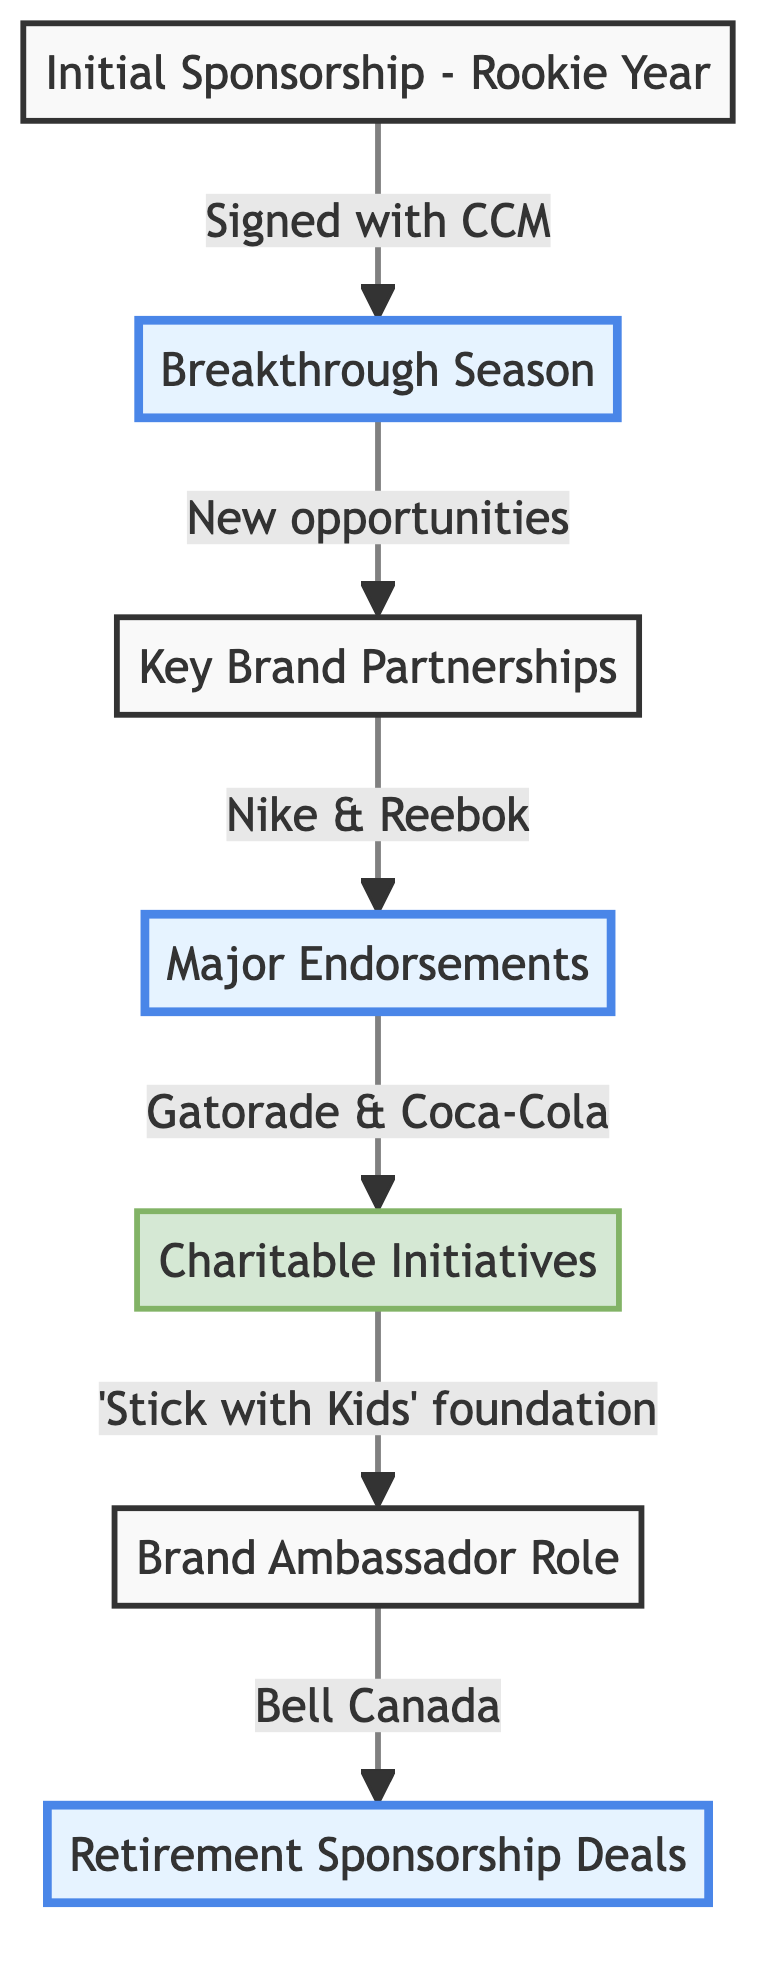What is the first step in the journey? The first step is the "Initial Sponsorship - Rookie Year," which is where the journey begins. This node indicates the signing of the first endorsement deal with CCM.
Answer: Initial Sponsorship - Rookie Year How many major endorsements are listed in the flow chart? There are two major endorsements listed in the flow chart: Gatorade and Coca-Cola. You can identify these from the "Major Endorsements" node connection.
Answer: 2 What partnership follows the "Breakthrough Season"? After achieving prominence in the "Breakthrough Season," the next step is "Key Brand Partnerships" where relationships with brands like Nike and Reebok are established.
Answer: Key Brand Partnerships What charitable initiative is mentioned? The flow chart mentions the "Stick with Kids" foundation, which focuses on supporting youth hockey programs. This is found under the "Charitable Initiatives" node.
Answer: Stick with Kids Which brand did the athlete represent as an ambassador? The athlete became a brand ambassador for Bell Canada, as indicated in the "Brand Ambassador Role" node.
Answer: Bell Canada What signifies a move from playing to endorsing after retirement? The transition is represented by the "Retirement Sponsorship Deals," where the athlete continues collaborations with existing brands and establishes new partnerships, such as with EA Sports.
Answer: Retirement Sponsorship Deals Which two brands are part of "Key Brand Partnerships"? Nike and Reebok are the two brands mentioned in the "Key Brand Partnerships" node. This node indicates the established relationships with those brands.
Answer: Nike and Reebok What is the connection between "Major Endorsements" and "Charitable Initiatives"? The connection indicates that following the "Major Endorsements" (Gatorade and Coca-Cola), there is a progression to "Charitable Initiatives" where the athlete launches their foundation.
Answer: Charitable Initiatives 